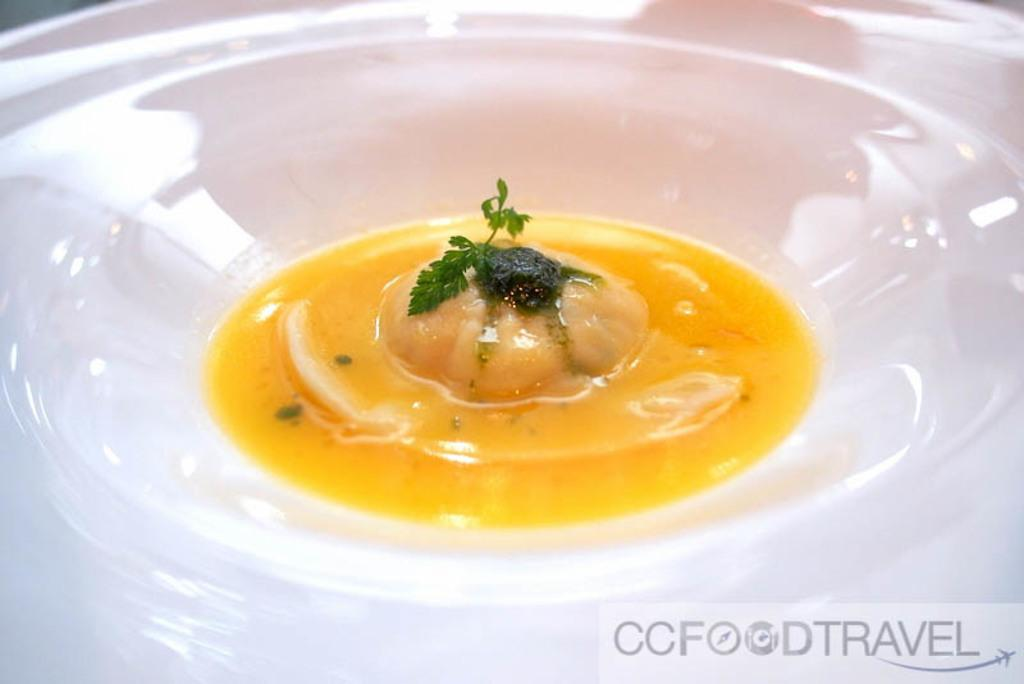What is present in the image that can hold food? There is a bowl in the image that can hold food. What type of food is in the bowl? The bowl contains food that is garnished with coriander. Can you describe the garnish used in the image? The food in the bowl is garnished with coriander. What type of boundary can be seen in the image? There is no boundary present in the image; it features a bowl of food garnished with coriander. Is there a camera visible in the image? There is no camera present in the image. 